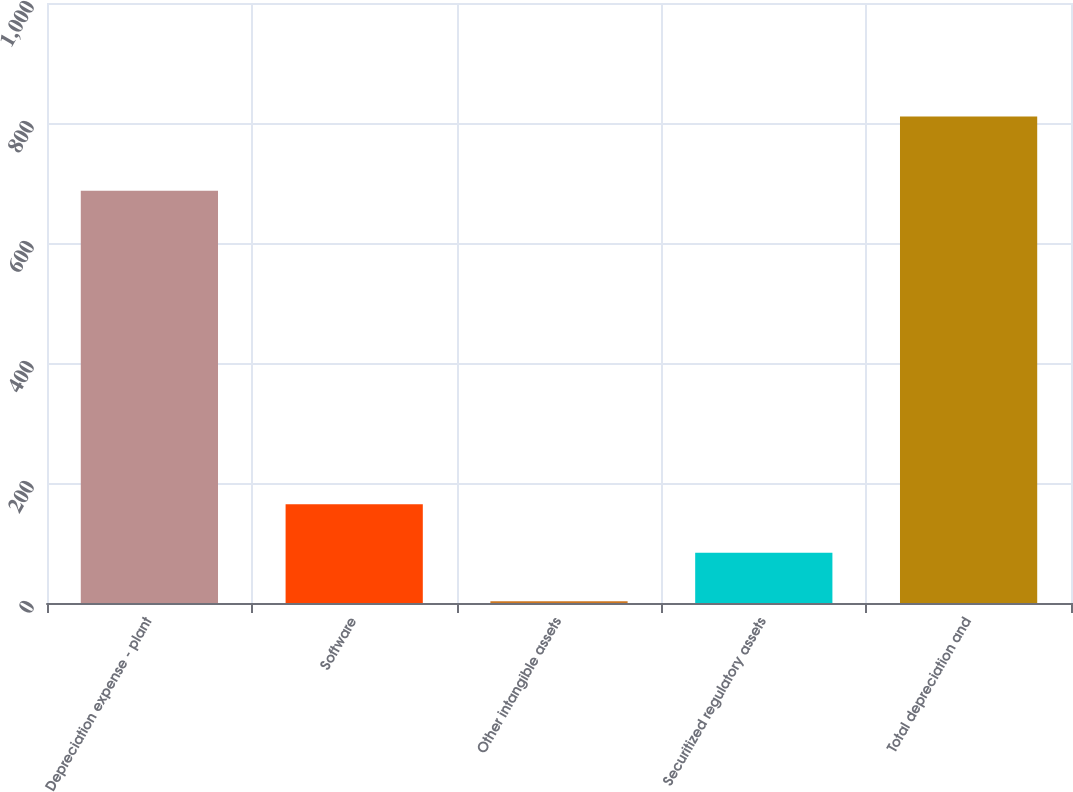Convert chart to OTSL. <chart><loc_0><loc_0><loc_500><loc_500><bar_chart><fcel>Depreciation expense - plant<fcel>Software<fcel>Other intangible assets<fcel>Securitized regulatory assets<fcel>Total depreciation and<nl><fcel>687<fcel>164.6<fcel>3<fcel>83.8<fcel>811<nl></chart> 